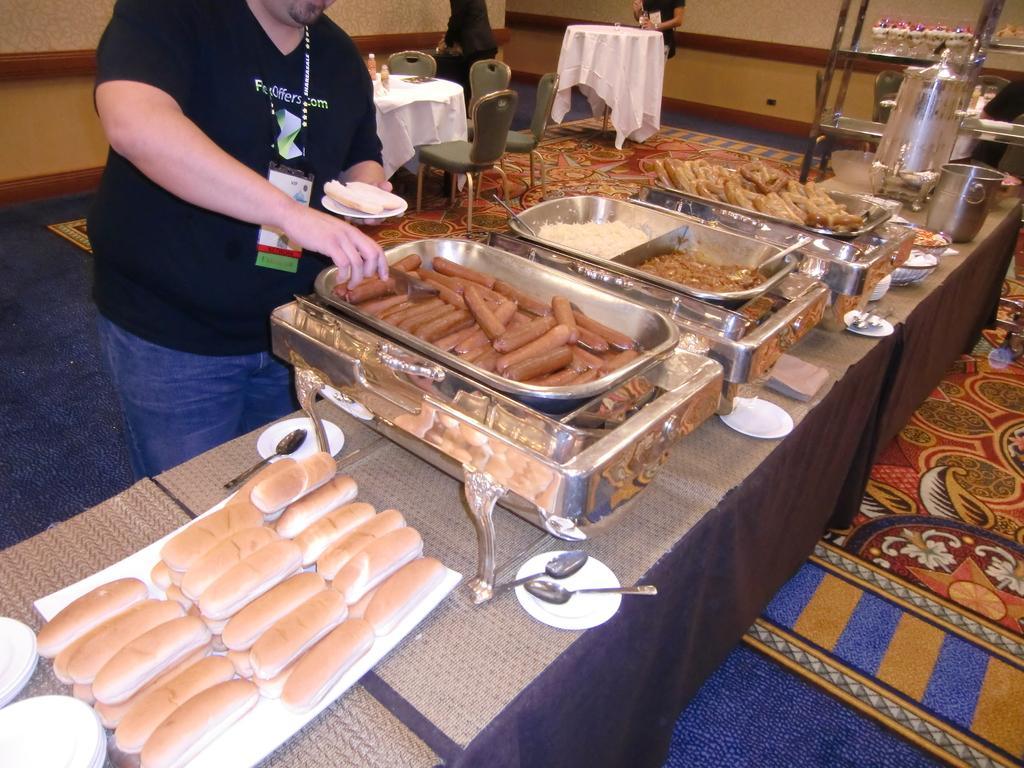Can you describe this image briefly? In this picture we can see so many items are placed on the table, one person is holding plate, behind we can see some chairs and tables are arranged. 